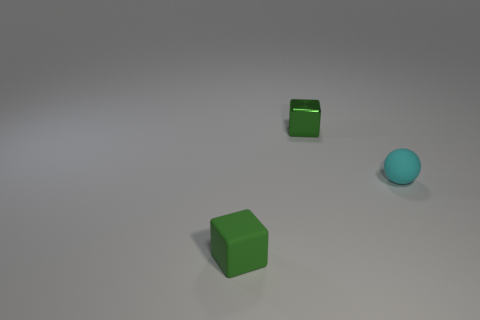What number of cubes are in front of the green metallic cube?
Ensure brevity in your answer.  1. Is there another rubber sphere of the same size as the cyan ball?
Give a very brief answer. No. Is the color of the small shiny cube the same as the matte ball?
Your response must be concise. No. The tiny matte sphere that is right of the tiny green cube in front of the metallic object is what color?
Your answer should be very brief. Cyan. What number of small cubes are both in front of the green shiny object and behind the small green rubber object?
Your answer should be very brief. 0. How many other shiny things are the same shape as the cyan object?
Provide a succinct answer. 0. There is a tiny thing on the left side of the green cube behind the small rubber sphere; what shape is it?
Offer a very short reply. Cube. There is a matte thing that is on the left side of the shiny object; how many green matte things are right of it?
Your answer should be very brief. 0. There is a tiny thing that is both on the left side of the small cyan thing and in front of the shiny cube; what is its material?
Give a very brief answer. Rubber. There is a green rubber object that is the same size as the cyan sphere; what shape is it?
Offer a terse response. Cube. 